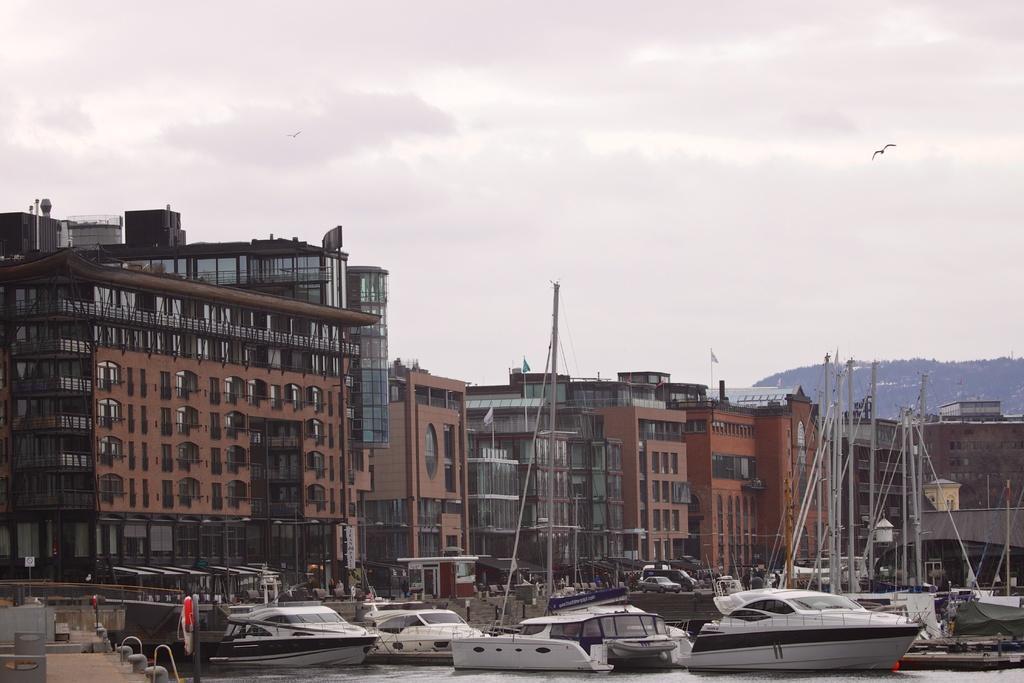How would you summarize this image in a sentence or two? At the bottom of the image I can see few boats on the water. On the left side there is a platform. In the background there are many buildings. At the top of the image I can see the sky and also I can see two birds are flying in the air. 